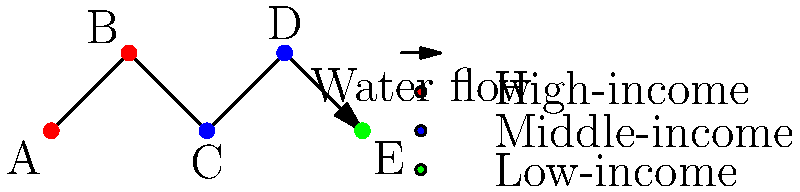The diagram represents a simplified water distribution system across different socioeconomic areas. Nodes A and B represent high-income areas, C and D represent middle-income areas, and E represents a low-income area. Assuming equal water pressure throughout the system, which socioeconomic group is most likely to experience water scarcity issues, and why? To answer this question, we need to consider the following factors:

1. Network structure: The water flows from A to E, passing through all other nodes.

2. Socioeconomic distribution:
   - High-income areas: A and B (first in line)
   - Middle-income areas: C and D (in the middle)
   - Low-income area: E (last in line)

3. Water consumption patterns:
   - High-income areas typically consume more water due to larger properties, swimming pools, and more water-intensive appliances.
   - Middle-income areas generally have moderate water consumption.
   - Low-income areas often have lower water consumption due to smaller living spaces and fewer water-intensive amenities.

4. Water pressure and flow:
   - Assuming equal initial pressure, the water flow decreases as it moves through the system due to consumption at each node.
   - The farther a node is from the source, the lower the water pressure and flow rate.

5. Socioeconomic implications:
   - High-income areas (A and B) have first access to the water supply and are likely to consume more, potentially leaving less for downstream users.
   - Middle-income areas (C and D) receive water after high-income areas but before the low-income area.
   - The low-income area (E) is last in line and may receive less water due to upstream consumption.

Considering these factors, the low-income area (E) is most likely to experience water scarcity issues because:
   a) It is the last node in the distribution system, receiving water after all other areas.
   b) Upstream consumption, especially in high-income areas, may significantly reduce available water.
   c) Low-income areas often have less political and economic influence to advocate for improved infrastructure or water allocation.

This situation highlights the importance of considering social equity in water distribution system design and management.
Answer: Low-income area (E) 